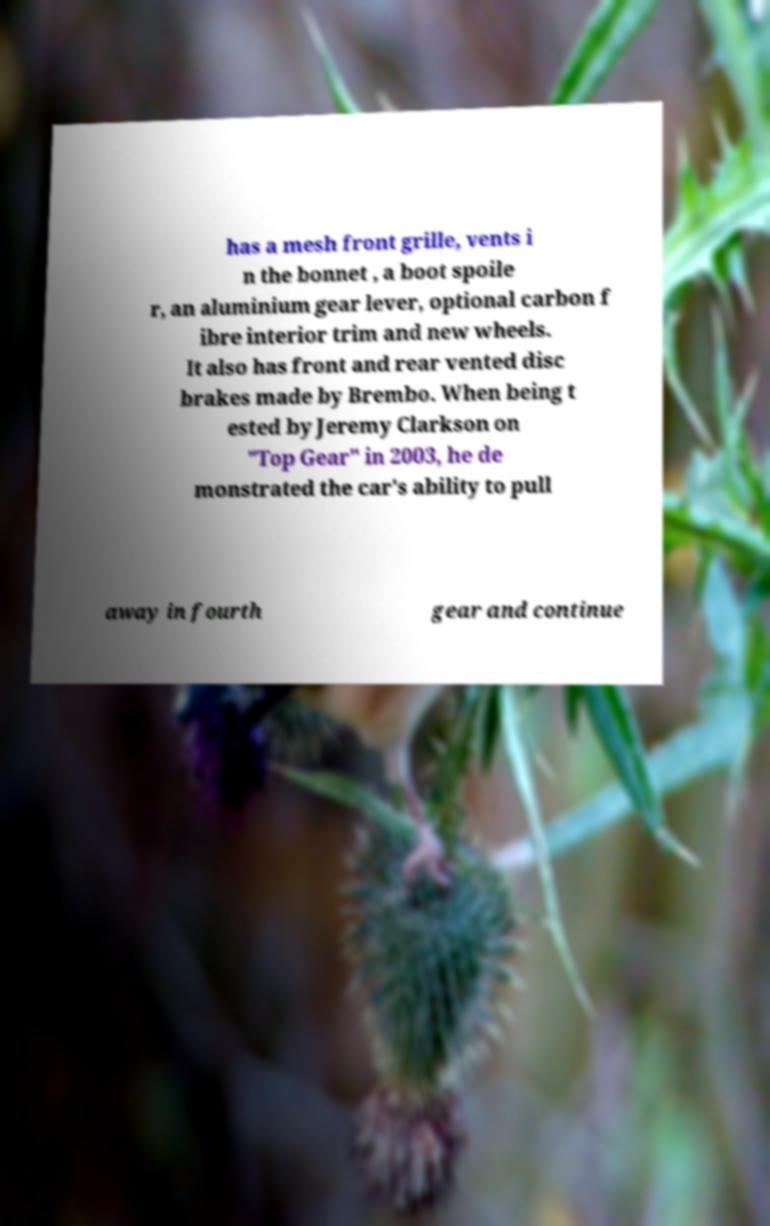There's text embedded in this image that I need extracted. Can you transcribe it verbatim? has a mesh front grille, vents i n the bonnet , a boot spoile r, an aluminium gear lever, optional carbon f ibre interior trim and new wheels. It also has front and rear vented disc brakes made by Brembo. When being t ested by Jeremy Clarkson on "Top Gear" in 2003, he de monstrated the car's ability to pull away in fourth gear and continue 